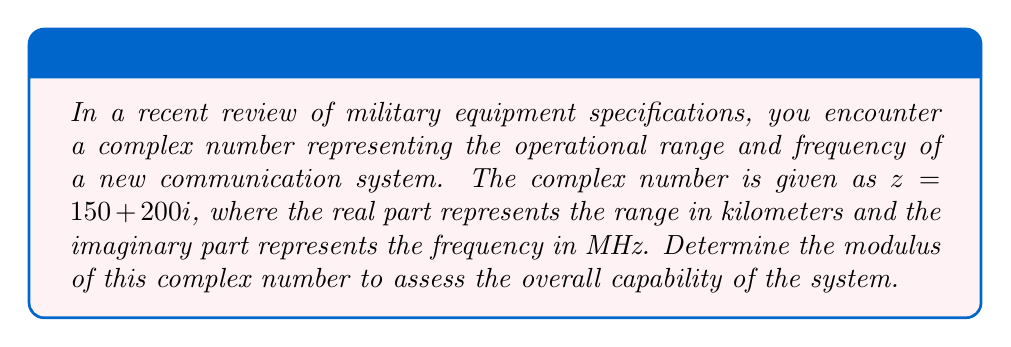What is the answer to this math problem? To determine the modulus of a complex number $z = a + bi$, we use the formula:

$$ |z| = \sqrt{a^2 + b^2} $$

Where:
$|z|$ is the modulus of the complex number
$a$ is the real part
$b$ is the imaginary part

For our given complex number $z = 150 + 200i$:
$a = 150$ (range in km)
$b = 200$ (frequency in MHz)

Let's substitute these values into the formula:

$$ |z| = \sqrt{150^2 + 200^2} $$

Now, let's calculate:

$$ |z| = \sqrt{22,500 + 40,000} $$
$$ |z| = \sqrt{62,500} $$
$$ |z| = 250 $$

The modulus of the complex number is 250. This value represents the Euclidean distance from the origin to the point (150, 200) in the complex plane, giving us a single measure of the system's overall capability.
Answer: $250$ 